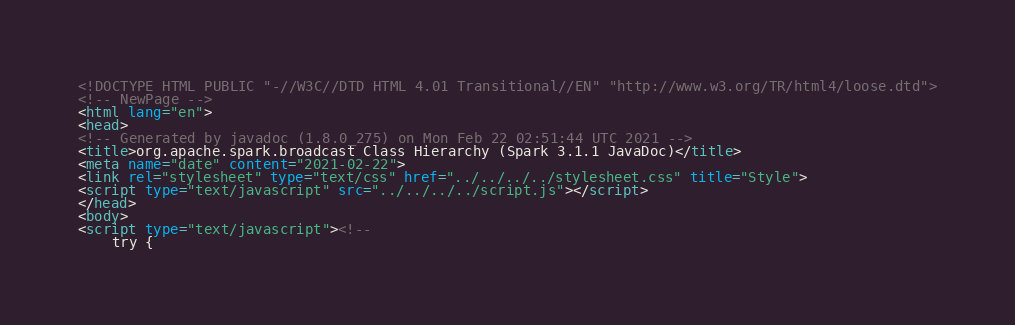<code> <loc_0><loc_0><loc_500><loc_500><_HTML_><!DOCTYPE HTML PUBLIC "-//W3C//DTD HTML 4.01 Transitional//EN" "http://www.w3.org/TR/html4/loose.dtd">
<!-- NewPage -->
<html lang="en">
<head>
<!-- Generated by javadoc (1.8.0_275) on Mon Feb 22 02:51:44 UTC 2021 -->
<title>org.apache.spark.broadcast Class Hierarchy (Spark 3.1.1 JavaDoc)</title>
<meta name="date" content="2021-02-22">
<link rel="stylesheet" type="text/css" href="../../../../stylesheet.css" title="Style">
<script type="text/javascript" src="../../../../script.js"></script>
</head>
<body>
<script type="text/javascript"><!--
    try {</code> 